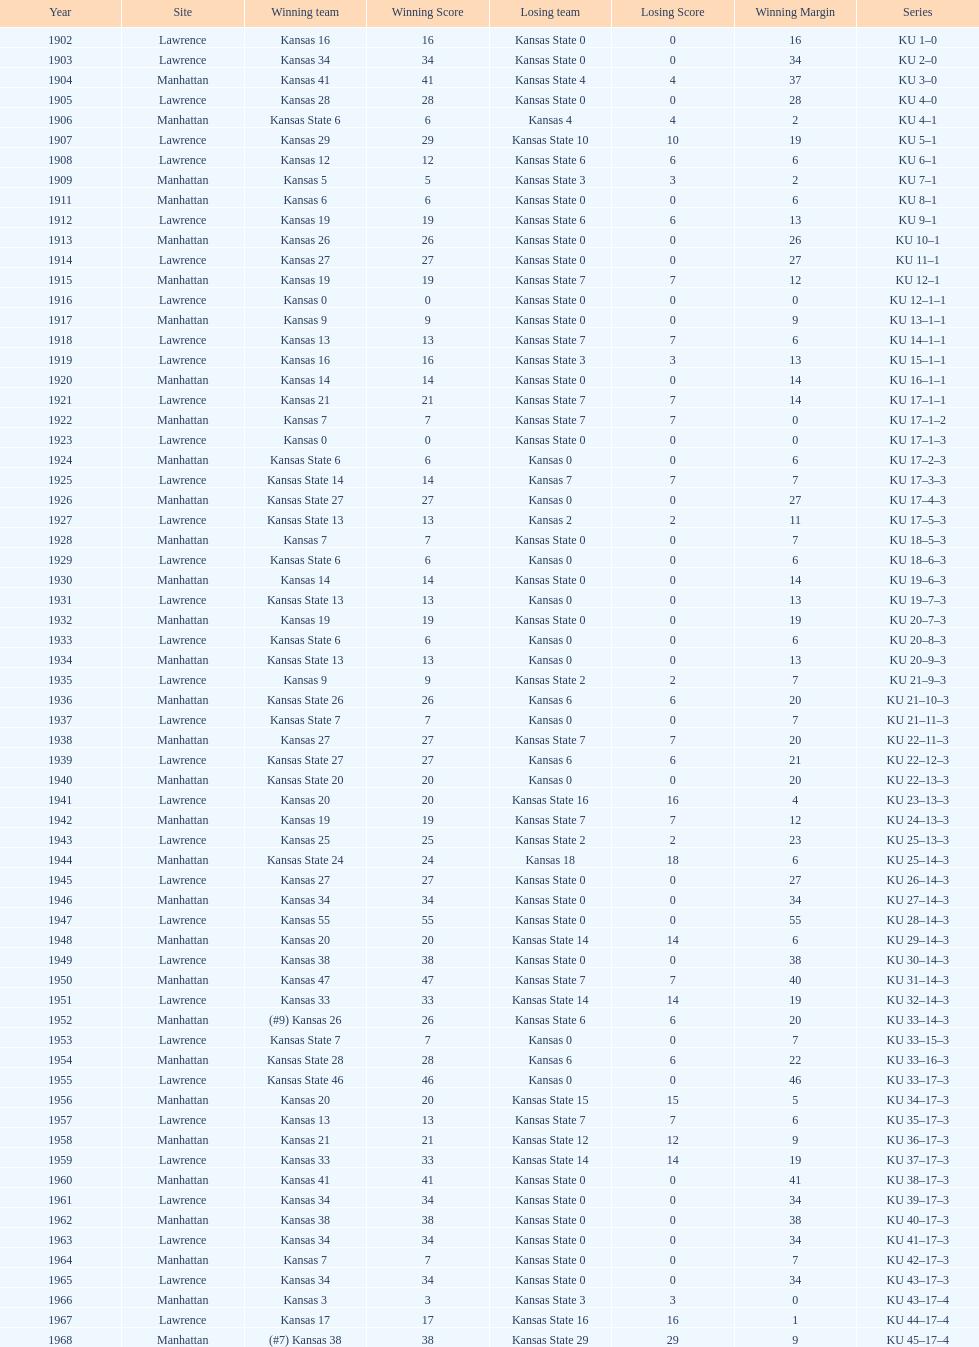How many times did kansas beat kansas state before 1910? 7. 